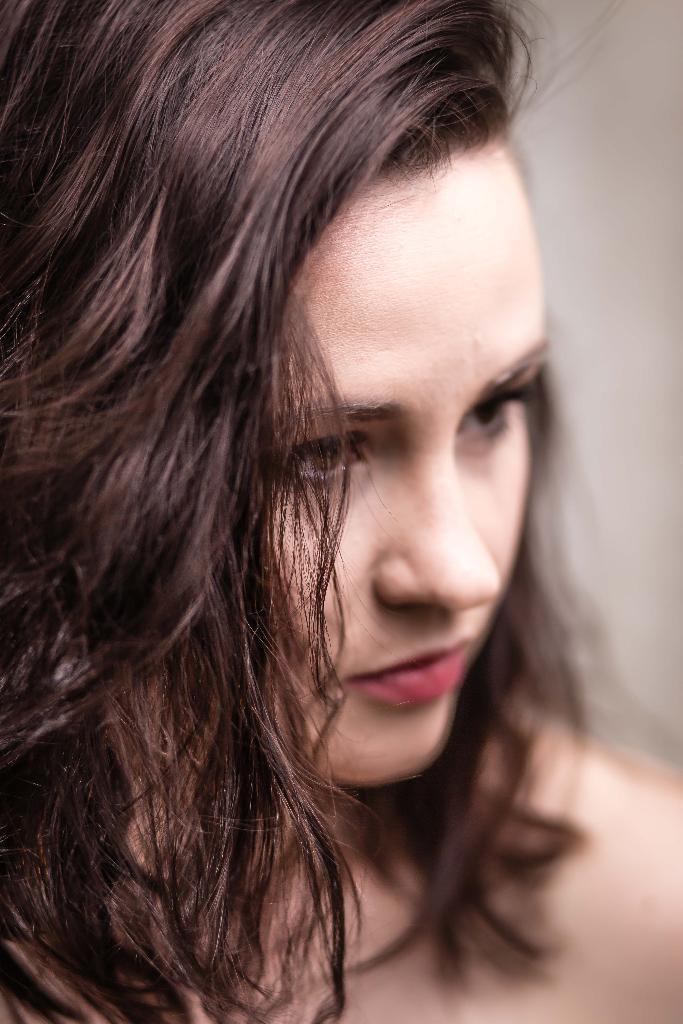How would you summarize this image in a sentence or two? This image consists of a girl. The background is blurred. 